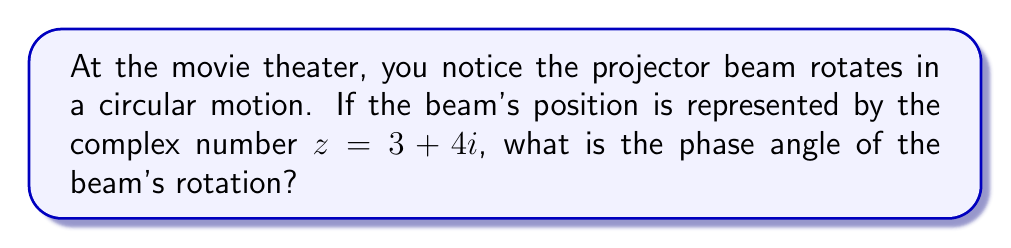Teach me how to tackle this problem. Let's approach this step-by-step:

1) The phase angle of a complex number is the angle it makes with the positive real axis in the complex plane.

2) For a complex number in the form $z = a + bi$, the phase angle $\theta$ is given by:

   $$\theta = \tan^{-1}\left(\frac{b}{a}\right)$$

3) In our case, $z = 3 + 4i$, so $a = 3$ and $b = 4$.

4) Substituting these values:

   $$\theta = \tan^{-1}\left(\frac{4}{3}\right)$$

5) Using a calculator or trigonometric tables:

   $$\theta \approx 0.9273 \text{ radians}$$

6) To convert to degrees, multiply by $\frac{180}{\pi}$:

   $$\theta \approx 0.9273 \cdot \frac{180}{\pi} \approx 53.13°$$

Therefore, the phase angle of the projector beam's rotation is approximately 53.13°.
Answer: $53.13°$ 